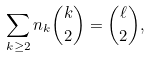Convert formula to latex. <formula><loc_0><loc_0><loc_500><loc_500>\sum _ { k \geq 2 } n _ { k } { { k } \choose { 2 } } = { { \ell } \choose { 2 } } ,</formula> 